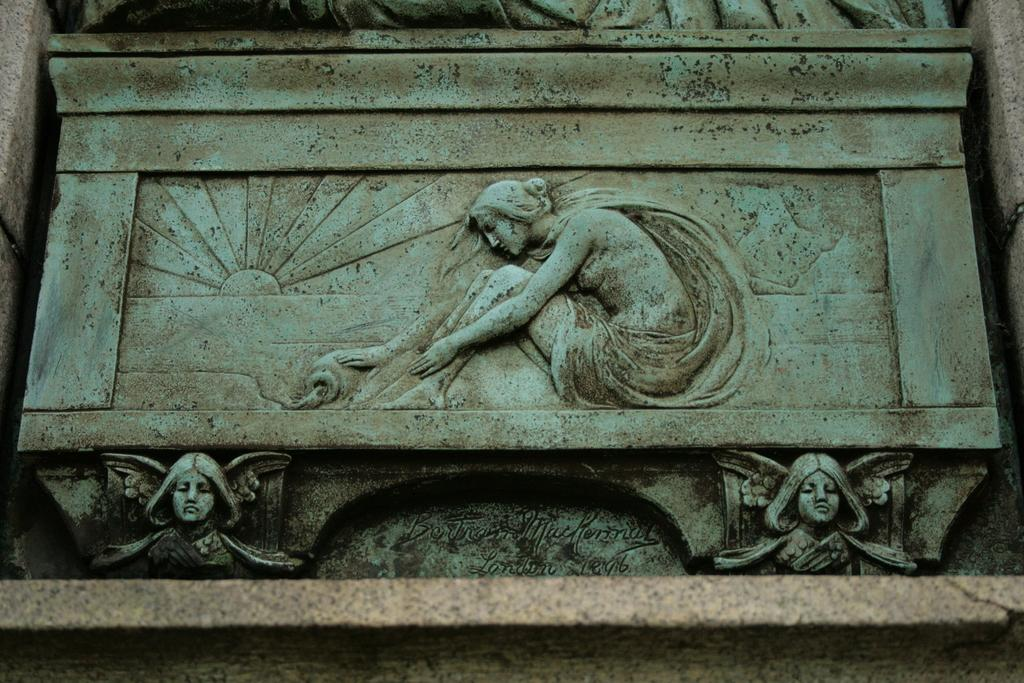What type of artwork can be seen in the image? There are sculptures in the image. What else is present on the wall in the image? There is text on the wall in the image. How many beads are hanging from the sculptures in the image? There is no mention of beads in the image, so it is impossible to determine their presence or quantity. 